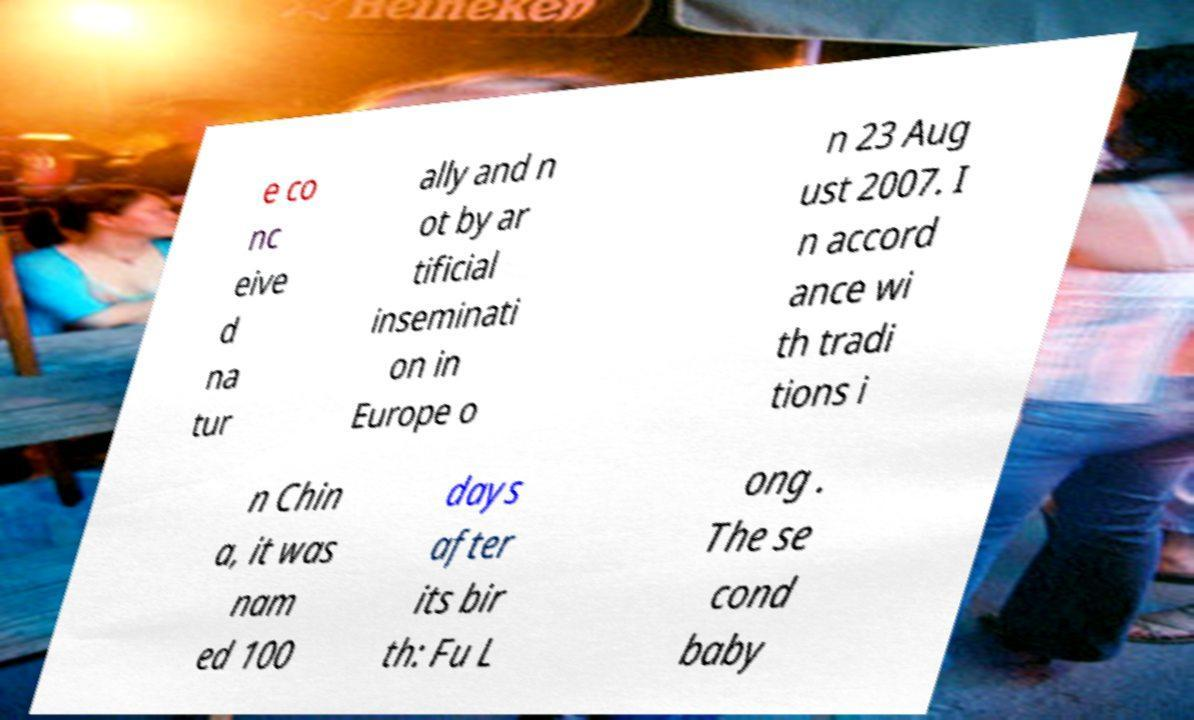There's text embedded in this image that I need extracted. Can you transcribe it verbatim? e co nc eive d na tur ally and n ot by ar tificial inseminati on in Europe o n 23 Aug ust 2007. I n accord ance wi th tradi tions i n Chin a, it was nam ed 100 days after its bir th: Fu L ong . The se cond baby 